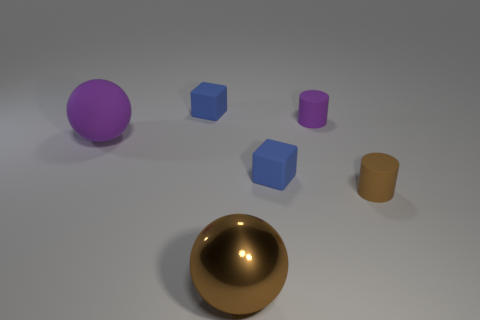Add 2 green matte blocks. How many objects exist? 8 Subtract all blocks. How many objects are left? 4 Add 2 large yellow metallic cylinders. How many large yellow metallic cylinders exist? 2 Subtract 0 brown cubes. How many objects are left? 6 Subtract all blocks. Subtract all matte balls. How many objects are left? 3 Add 2 brown cylinders. How many brown cylinders are left? 3 